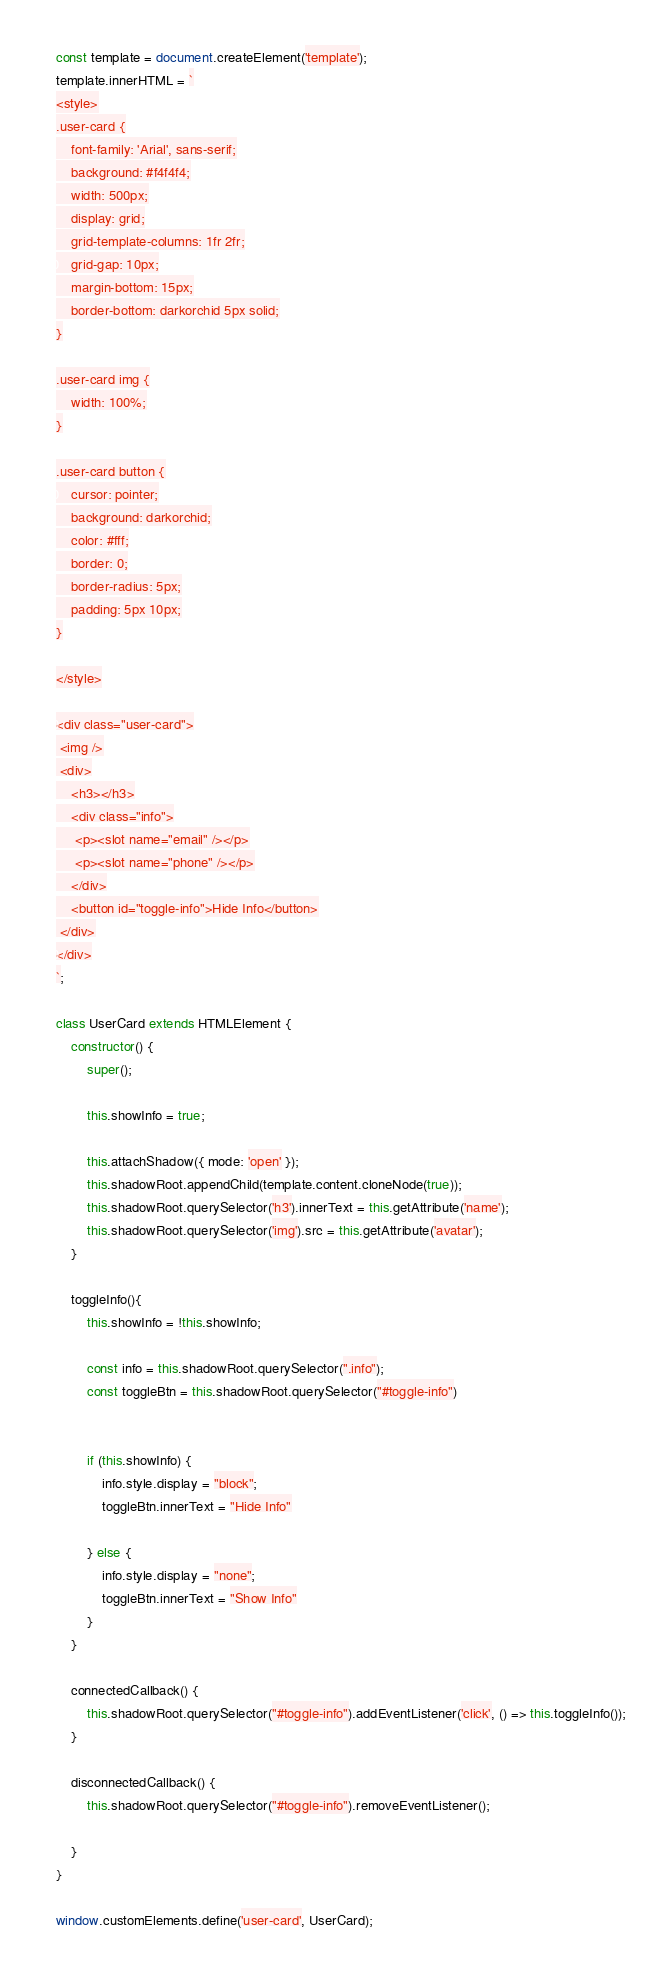<code> <loc_0><loc_0><loc_500><loc_500><_JavaScript_>const template = document.createElement('template');
template.innerHTML = `
<style>
.user-card {
    font-family: 'Arial', sans-serif;
    background: #f4f4f4;
    width: 500px;
    display: grid;
    grid-template-columns: 1fr 2fr;
    grid-gap: 10px;
    margin-bottom: 15px;
    border-bottom: darkorchid 5px solid;
}

.user-card img {
    width: 100%;
}

.user-card button {
    cursor: pointer;
    background: darkorchid;
    color: #fff;
    border: 0;
    border-radius: 5px;
    padding: 5px 10px;
}

</style>

<div class="user-card">
 <img />
 <div>
    <h3></h3>
    <div class="info">
     <p><slot name="email" /></p>
     <p><slot name="phone" /></p>
    </div>
    <button id="toggle-info">Hide Info</button>
 </div>
</div>
`;

class UserCard extends HTMLElement {
	constructor() {
		super();

        this.showInfo = true;

		this.attachShadow({ mode: 'open' });
		this.shadowRoot.appendChild(template.content.cloneNode(true));
		this.shadowRoot.querySelector('h3').innerText = this.getAttribute('name');
		this.shadowRoot.querySelector('img').src = this.getAttribute('avatar');
	}

    toggleInfo(){
        this.showInfo = !this.showInfo;

        const info = this.shadowRoot.querySelector(".info");
        const toggleBtn = this.shadowRoot.querySelector("#toggle-info")


        if (this.showInfo) {
            info.style.display = "block";
            toggleBtn.innerText = "Hide Info"

        } else {
            info.style.display = "none";
            toggleBtn.innerText = "Show Info"
        }
    }

    connectedCallback() {
        this.shadowRoot.querySelector("#toggle-info").addEventListener('click', () => this.toggleInfo());
    }

    disconnectedCallback() {
        this.shadowRoot.querySelector("#toggle-info").removeEventListener();

    }
}

window.customElements.define('user-card', UserCard);
</code> 